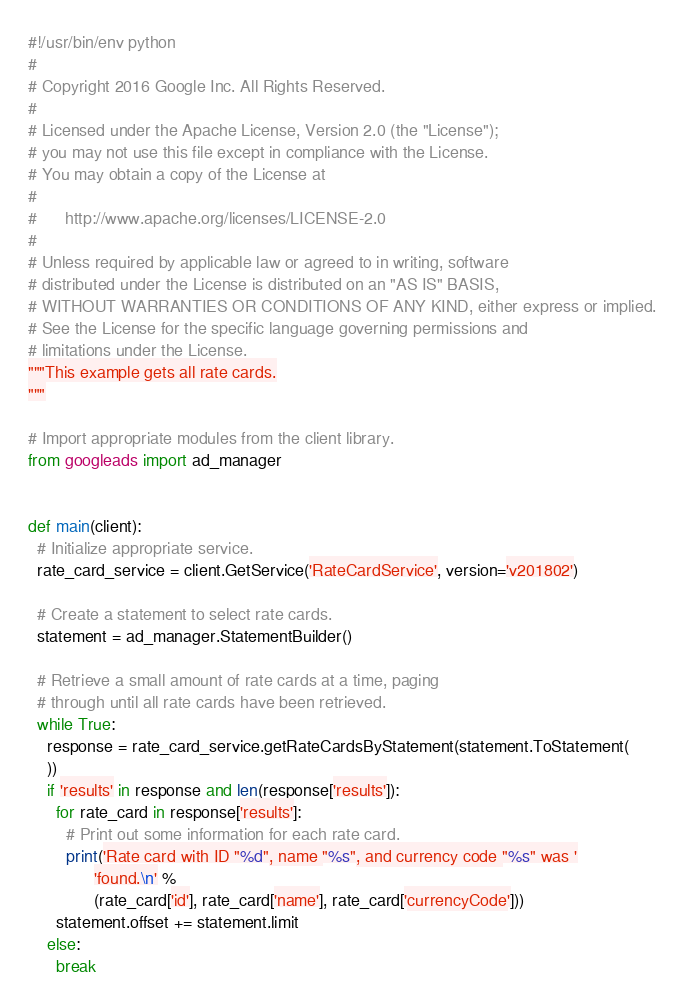<code> <loc_0><loc_0><loc_500><loc_500><_Python_>#!/usr/bin/env python
#
# Copyright 2016 Google Inc. All Rights Reserved.
#
# Licensed under the Apache License, Version 2.0 (the "License");
# you may not use this file except in compliance with the License.
# You may obtain a copy of the License at
#
#      http://www.apache.org/licenses/LICENSE-2.0
#
# Unless required by applicable law or agreed to in writing, software
# distributed under the License is distributed on an "AS IS" BASIS,
# WITHOUT WARRANTIES OR CONDITIONS OF ANY KIND, either express or implied.
# See the License for the specific language governing permissions and
# limitations under the License.
"""This example gets all rate cards.
"""

# Import appropriate modules from the client library.
from googleads import ad_manager


def main(client):
  # Initialize appropriate service.
  rate_card_service = client.GetService('RateCardService', version='v201802')

  # Create a statement to select rate cards.
  statement = ad_manager.StatementBuilder()

  # Retrieve a small amount of rate cards at a time, paging
  # through until all rate cards have been retrieved.
  while True:
    response = rate_card_service.getRateCardsByStatement(statement.ToStatement(
    ))
    if 'results' in response and len(response['results']):
      for rate_card in response['results']:
        # Print out some information for each rate card.
        print('Rate card with ID "%d", name "%s", and currency code "%s" was '
              'found.\n' %
              (rate_card['id'], rate_card['name'], rate_card['currencyCode']))
      statement.offset += statement.limit
    else:
      break
</code> 